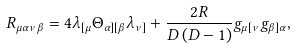Convert formula to latex. <formula><loc_0><loc_0><loc_500><loc_500>R _ { \mu \alpha \nu \beta } = 4 \lambda _ { [ \mu } \Theta _ { \alpha ] [ \beta } \lambda _ { \nu ] } + \frac { 2 R } { D \left ( D - 1 \right ) } g _ { \mu [ \nu } g _ { \beta ] \alpha } ,</formula> 